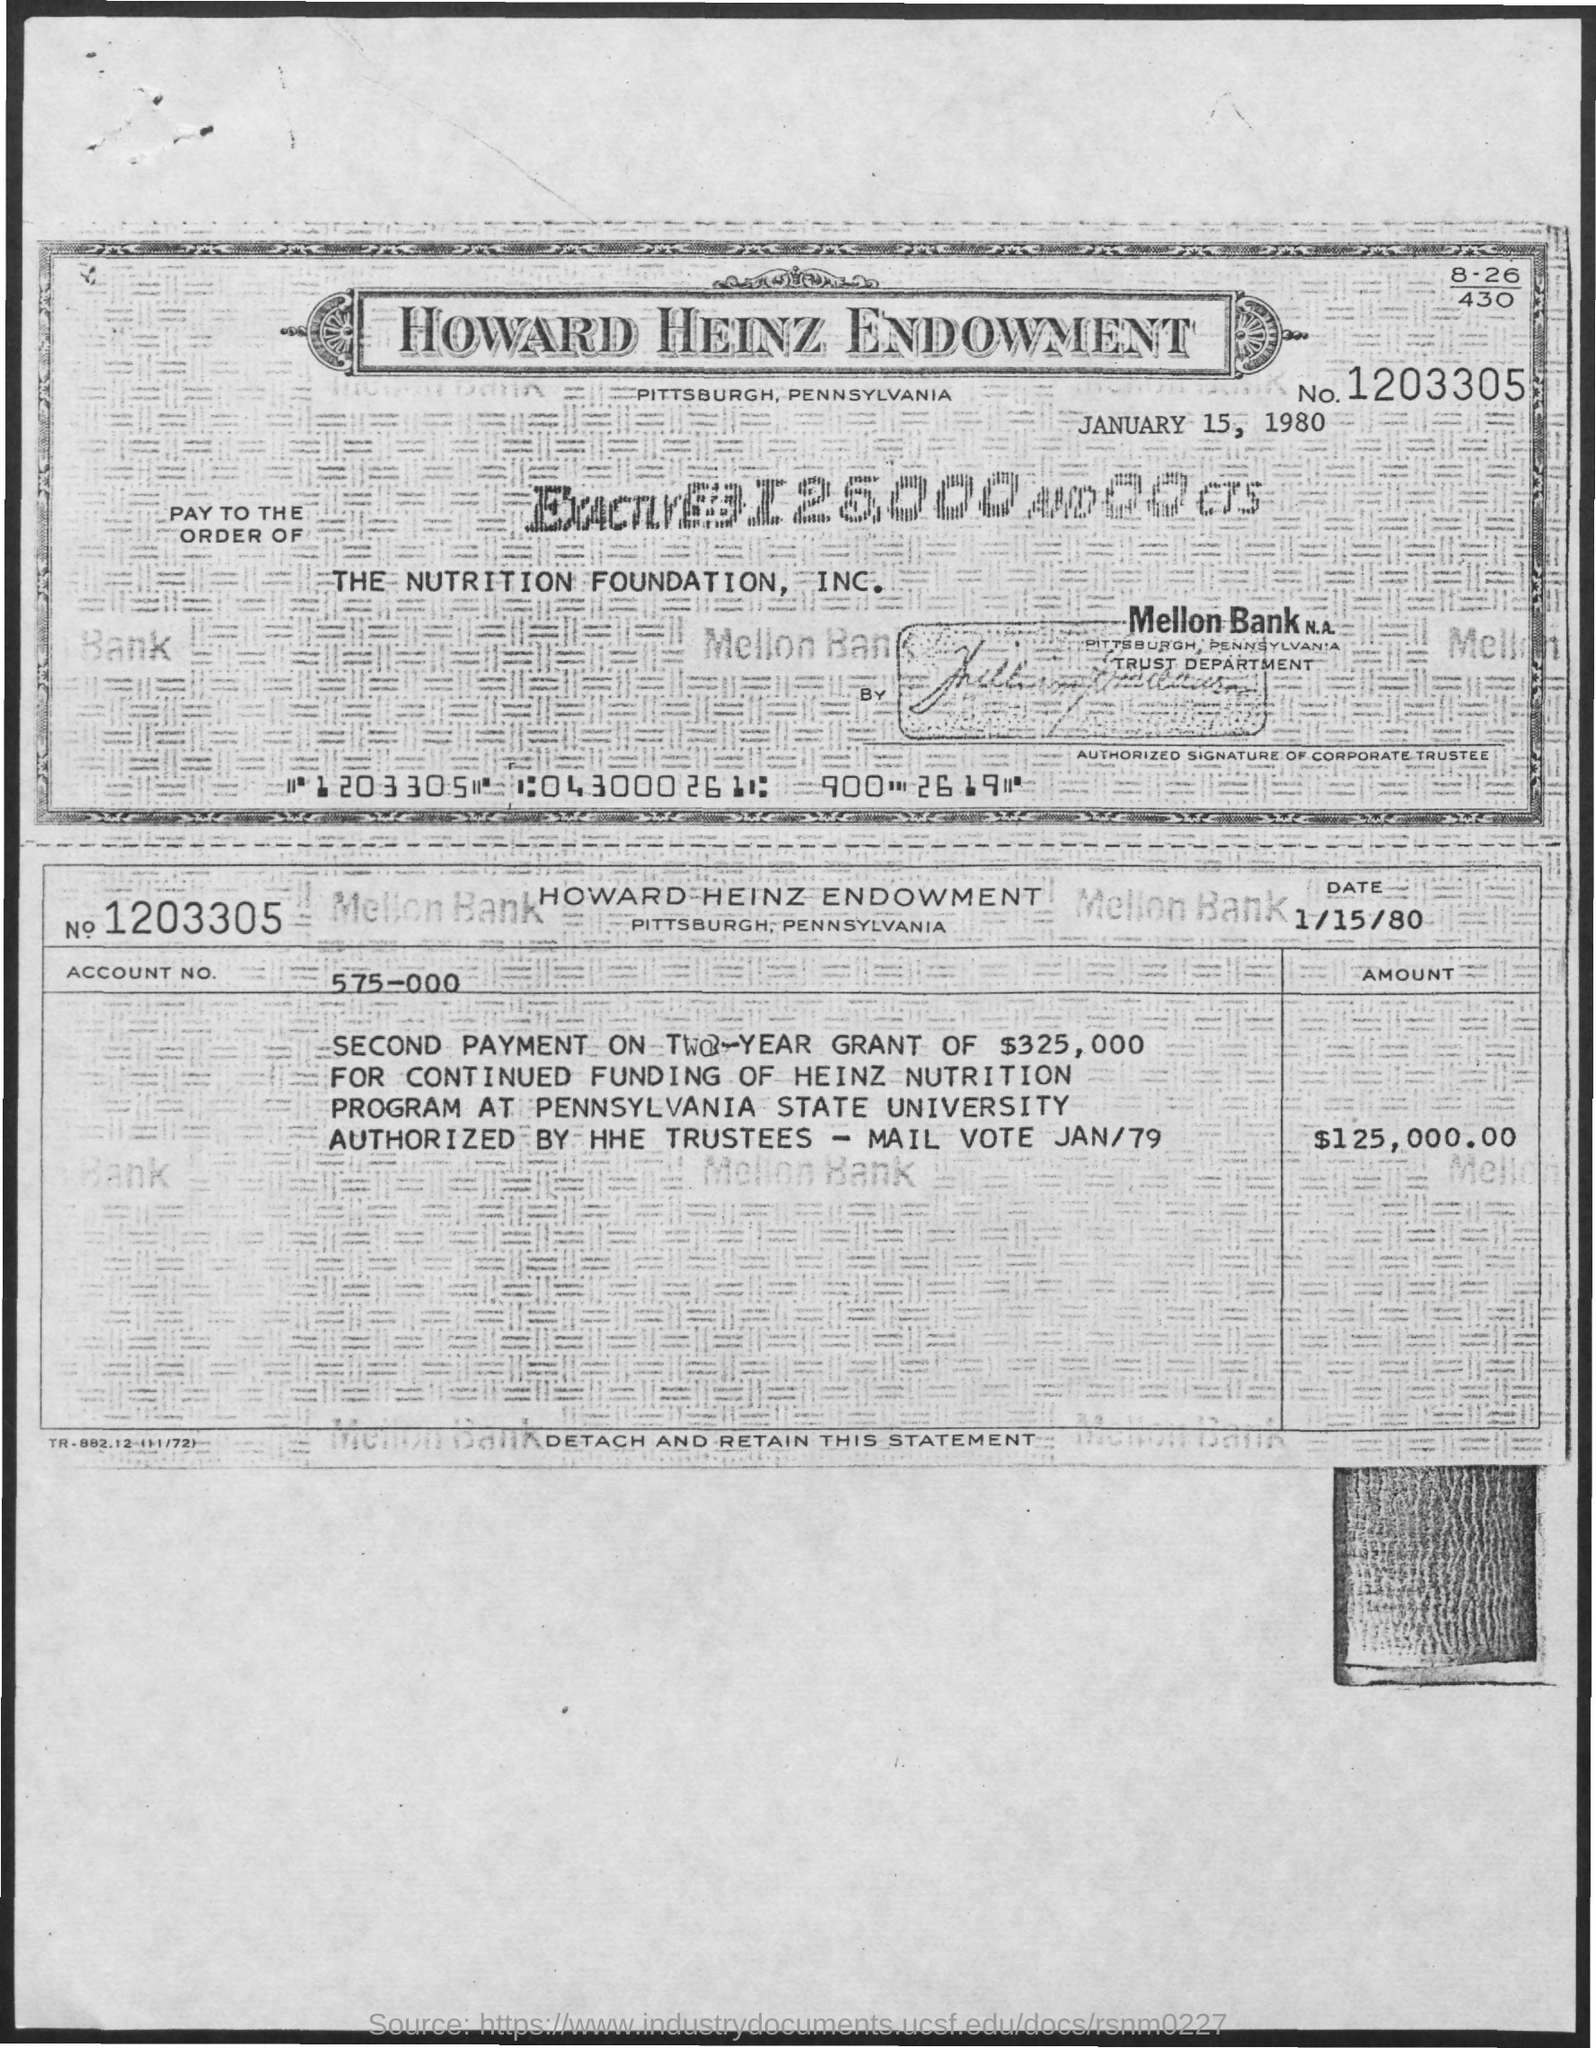Give some essential details in this illustration. In the company named THE NUTRITION FOUNDATION, INC, the check is issued. What is the check number given? 1203305... The amount of the check is $125,000.00. The check is dated January 15, 1980. The account number mentioned on the check is 575-000. 